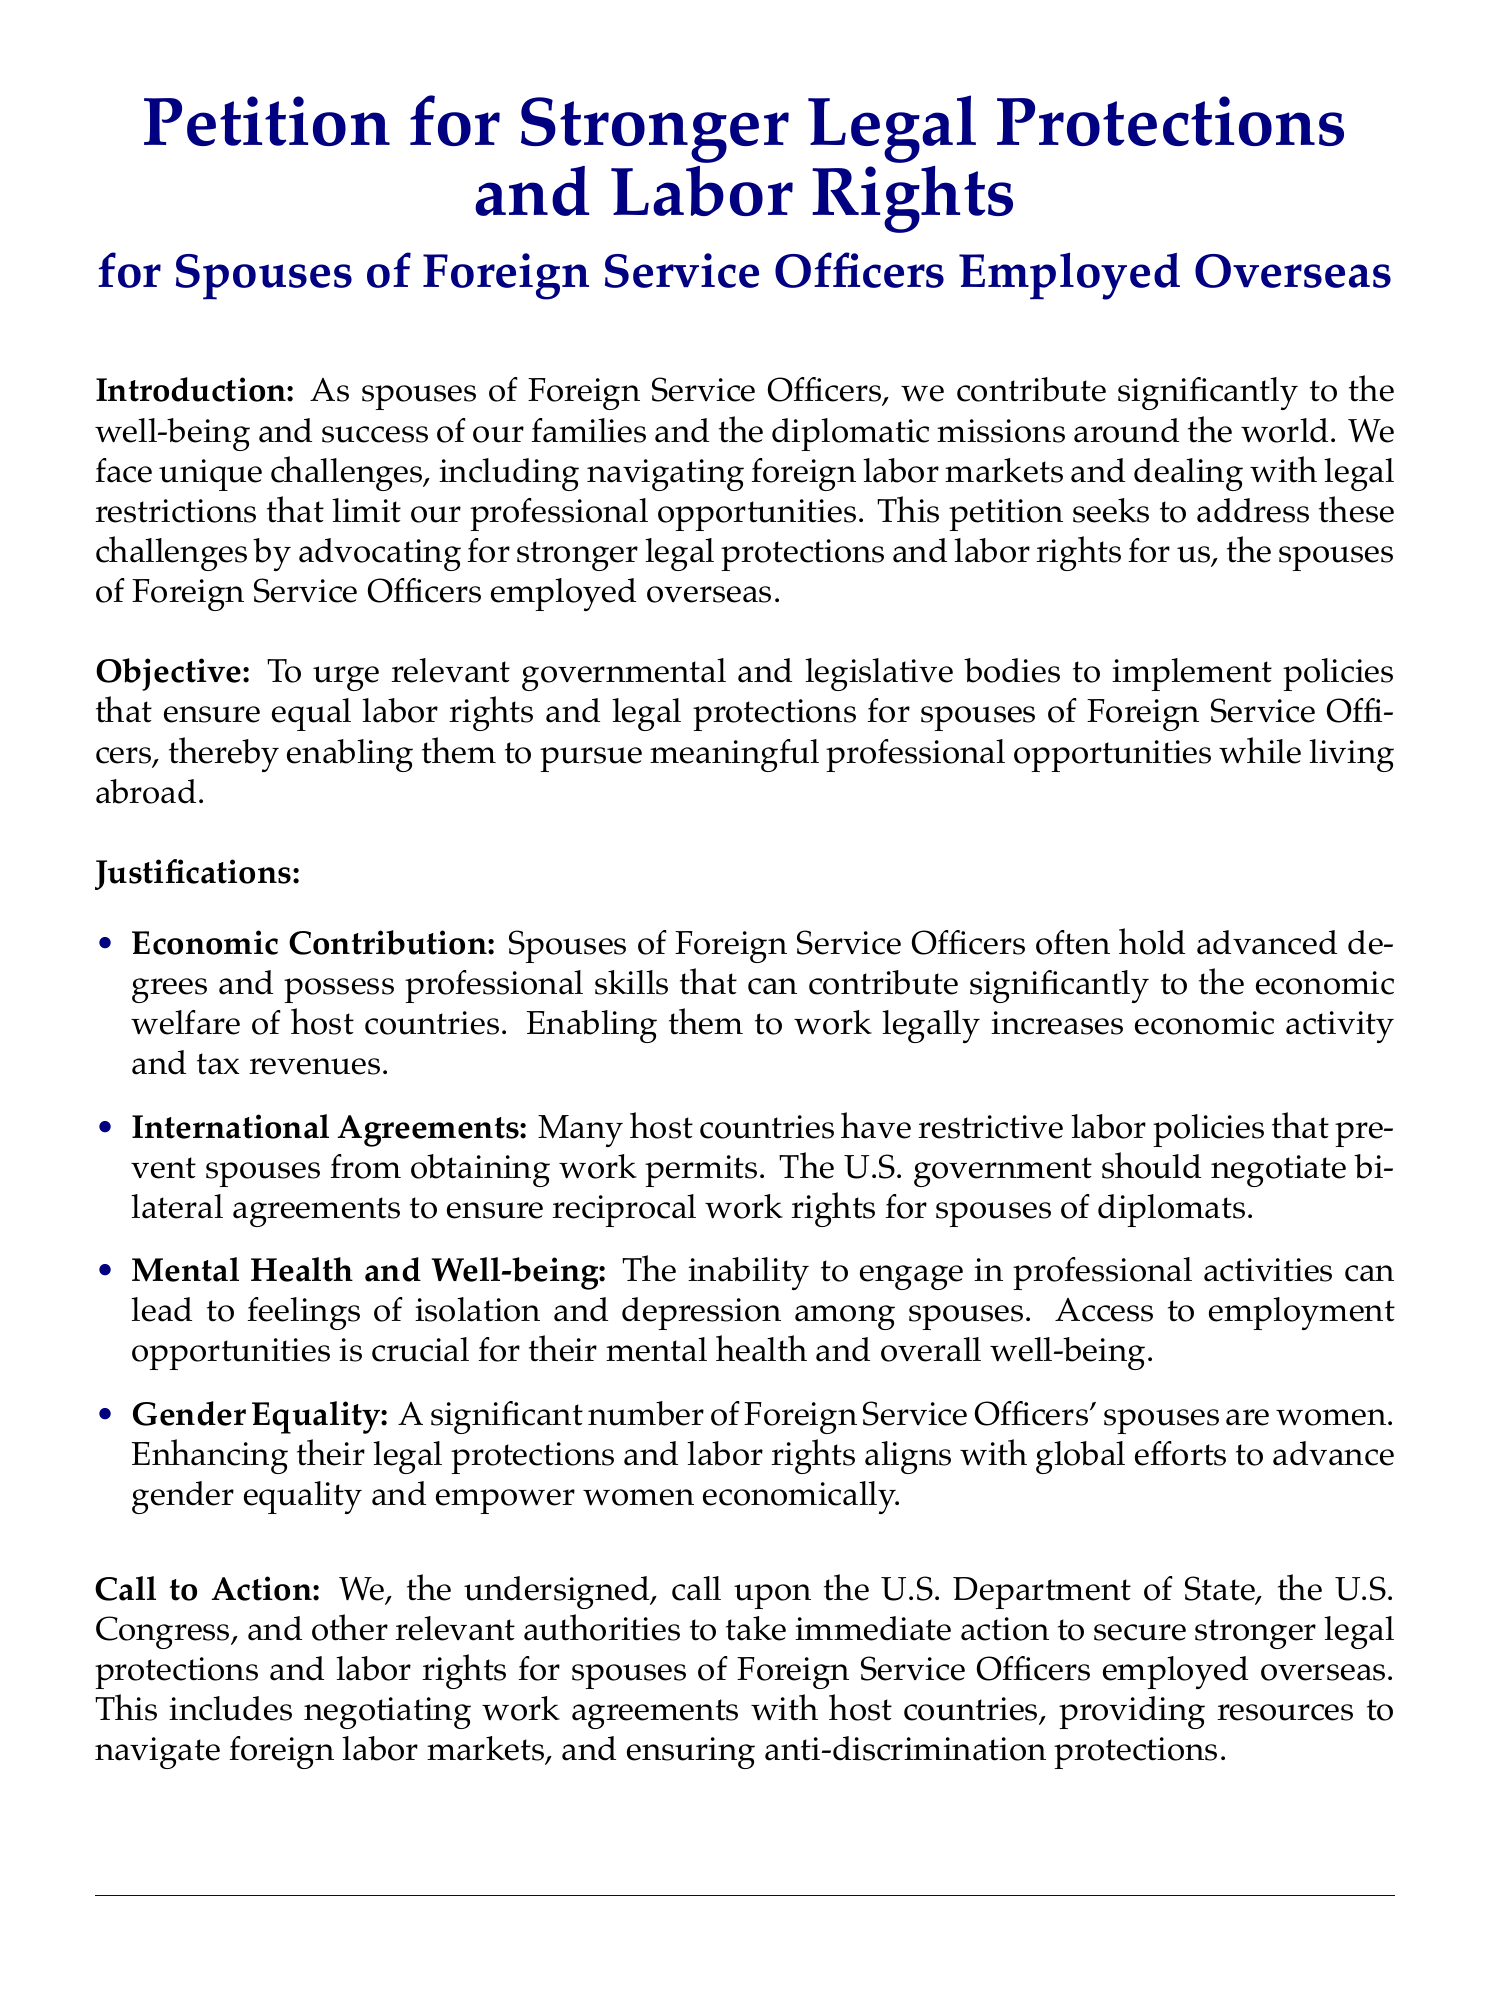what is the title of the petition? The title is prominently displayed at the beginning of the document and identifies the subject of the petition.
Answer: Petition for Stronger Legal Protections and Labor Rights what is the primary objective of the petition? The objective section outlines the main goal of the petition, which aims to advocate for certain rights.
Answer: To urge relevant governmental and legislative bodies to implement policies that ensure equal labor rights and legal protections how many key justifications are listed in the document? The section titled "Justifications" contains a bullet list detailing four specific points.
Answer: Four which government department is specifically called upon in the petition? The Call to Action section mentions a specific governing body that is being petitioned for action.
Answer: U.S. Department of State what is one reason mentioned for enhancing labor rights? The justification section provides various reasons for advocating labor rights, including the economic implications.
Answer: Economic Contribution who primarily suffers from mental health issues according to the petition? The document discusses the psychological impact on a specific group related to employment opportunities.
Answer: Spouses of Foreign Service Officers when should a signer provide their date? The document includes a space for the date next to where the signature is required, indicating when the petition is signed.
Answer: At the time of signing what personal information is requested from each signer? The petition asks for specific identifying information from each person who signs it.
Answer: Printed Name 